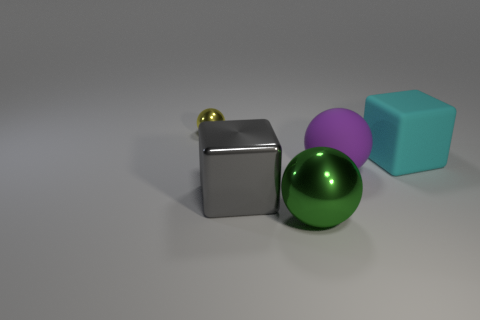Add 4 green objects. How many objects exist? 9 Subtract all blocks. How many objects are left? 3 Add 5 big gray things. How many big gray things are left? 6 Add 4 red blocks. How many red blocks exist? 4 Subtract 1 gray blocks. How many objects are left? 4 Subtract all large green things. Subtract all big green things. How many objects are left? 3 